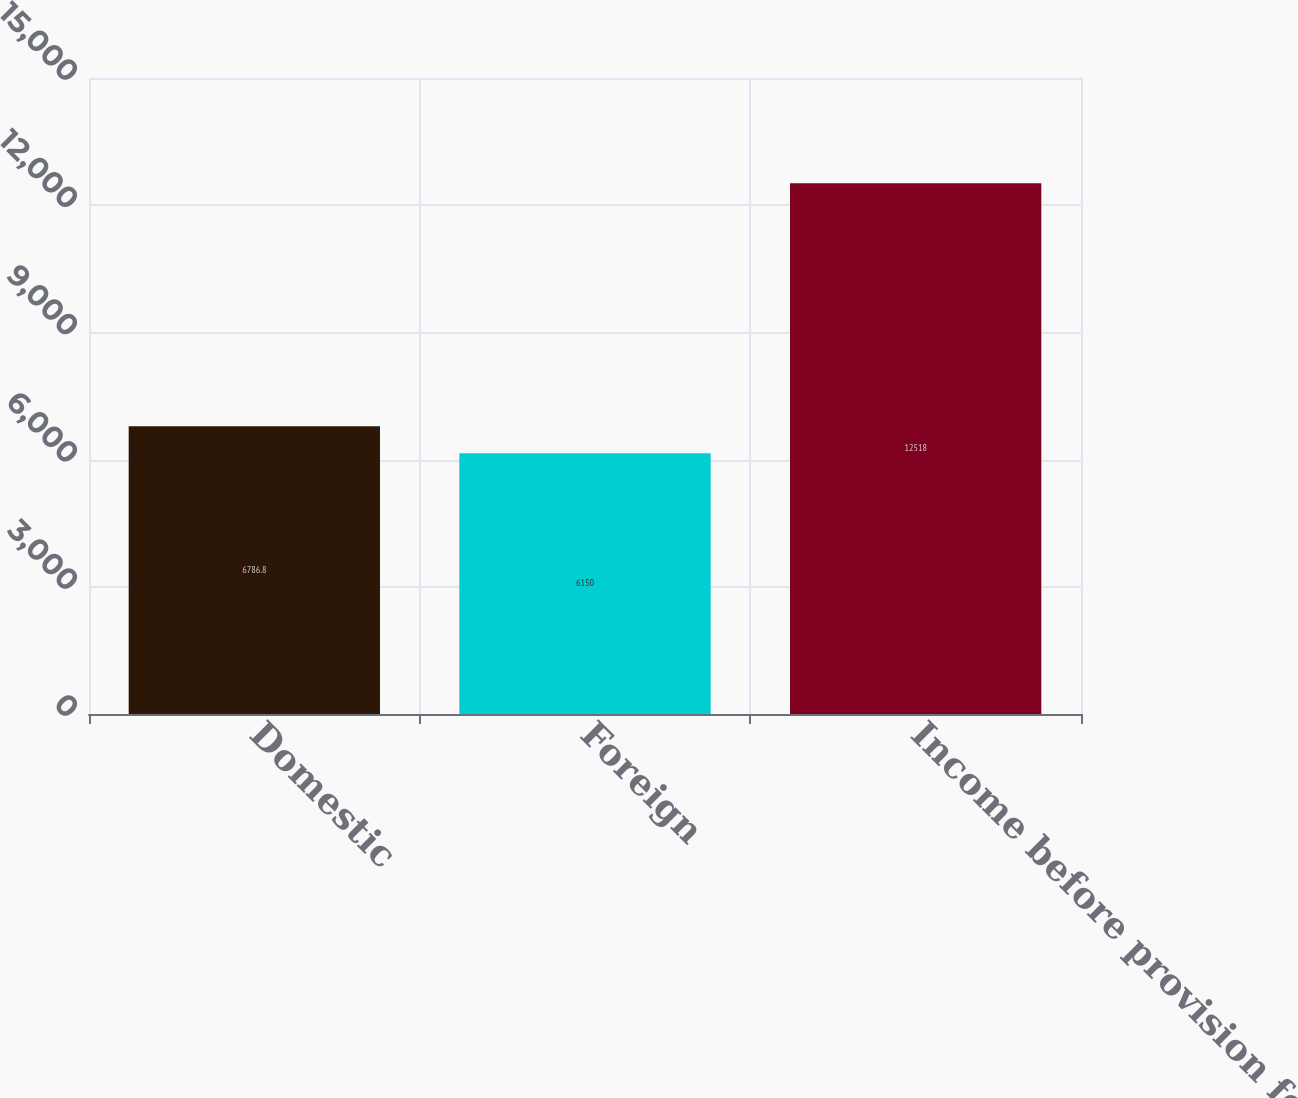<chart> <loc_0><loc_0><loc_500><loc_500><bar_chart><fcel>Domestic<fcel>Foreign<fcel>Income before provision for<nl><fcel>6786.8<fcel>6150<fcel>12518<nl></chart> 